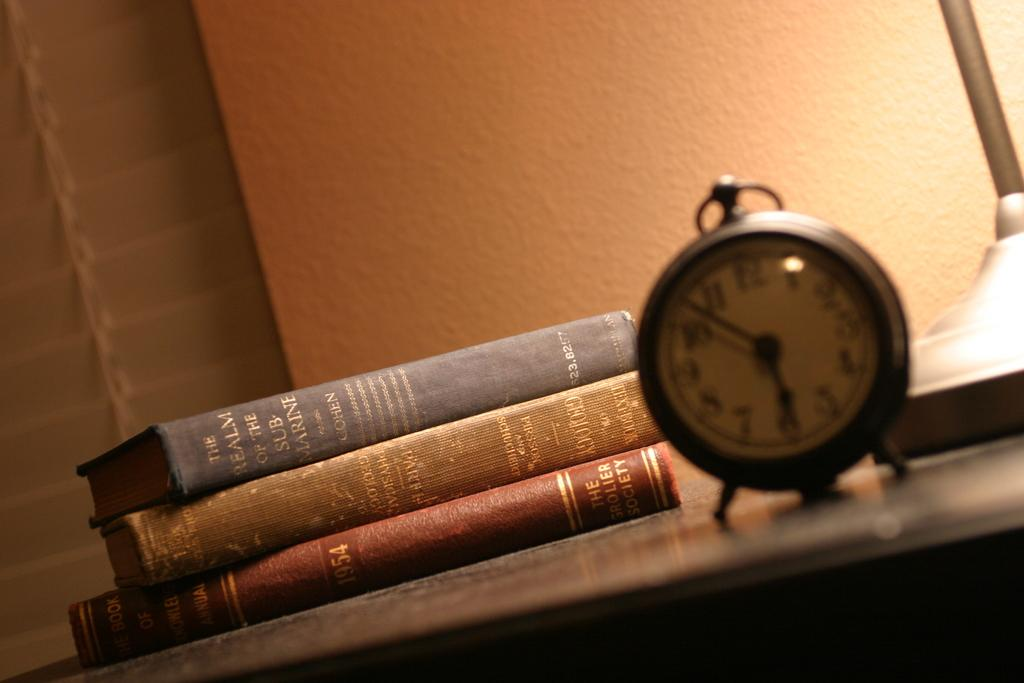<image>
Present a compact description of the photo's key features. Old fashioned round desk clock with round hoop at top for hanging next to 3 vintage books, one from 1954. 